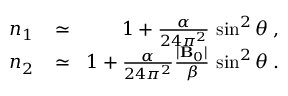Convert formula to latex. <formula><loc_0><loc_0><loc_500><loc_500>\begin{array} { r l r } { n _ { 1 } \, } & \simeq } & { \, 1 + \frac { \alpha } { 2 4 \pi ^ { 2 } } \, \sin ^ { 2 } \theta \, , } \\ { n _ { 2 } \, } & \simeq } & { \, 1 + \frac { \alpha } { 2 4 \pi ^ { 2 } } \frac { | { B } _ { 0 } | } { \beta } \, \sin ^ { 2 } \theta \, . } \end{array}</formula> 